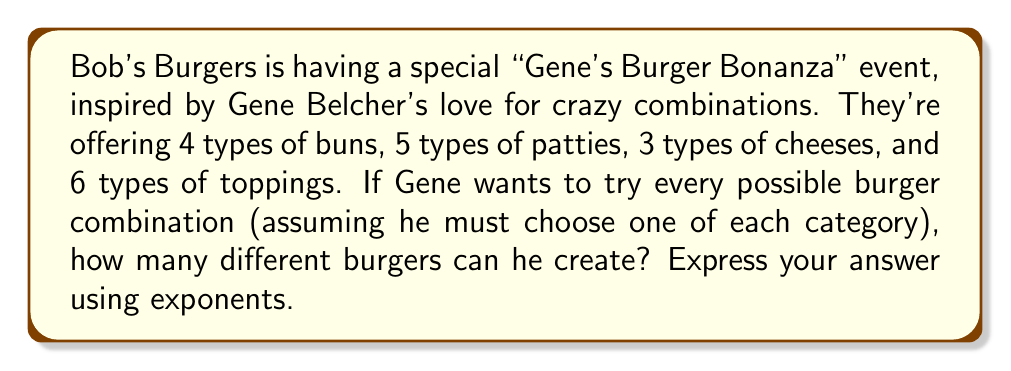Show me your answer to this math problem. Let's break this down step-by-step:

1) We need to use the multiplication principle of counting. This states that if we have multiple independent choices, we multiply the number of options for each choice.

2) In this case, we have four independent choices:
   - Buns: 4 options
   - Patties: 5 options
   - Cheeses: 3 options
   - Toppings: 6 options

3) To find the total number of combinations, we multiply these together:

   $4 \times 5 \times 3 \times 6$

4) We can rewrite this using exponents:

   $4^1 \times 5^1 \times 3^1 \times 6^1$

5) This can be simplified to:

   $4 \times 5 \times 3 \times 6 = 360$

Therefore, Gene can create 360 different burger combinations, which can be expressed as:

$$4^1 \times 5^1 \times 3^1 \times 6^1 = 360$$
Answer: $4^1 \times 5^1 \times 3^1 \times 6^1 = 360$ burger combinations 